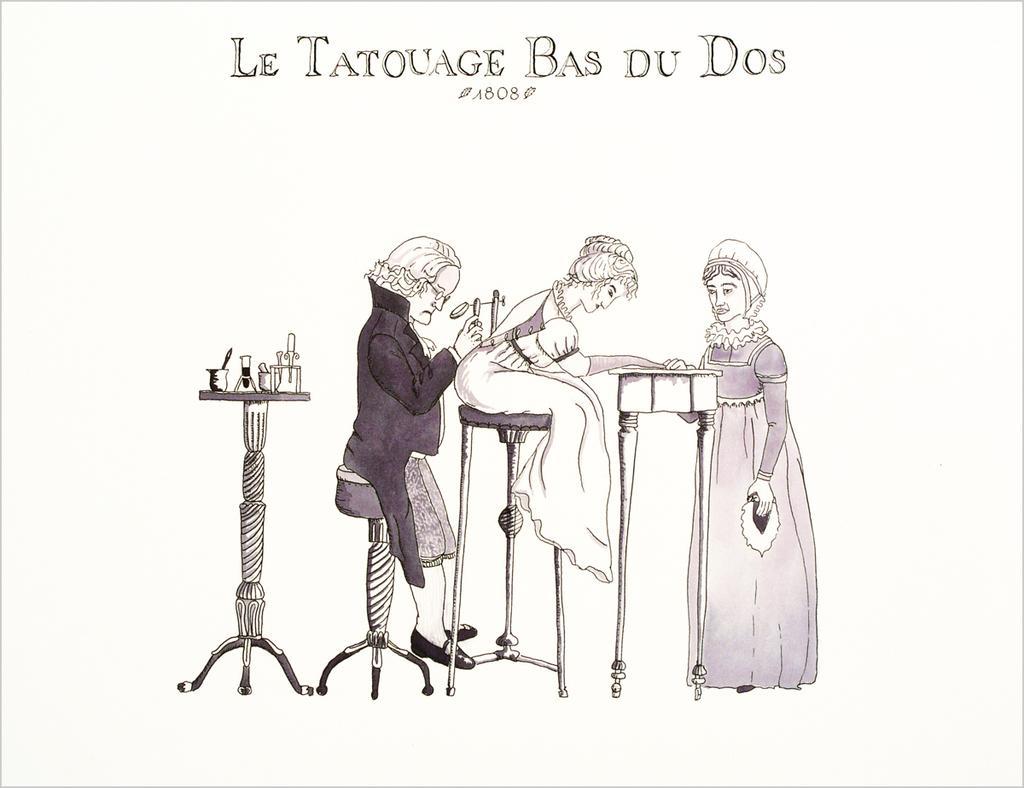Please provide a concise description of this image. This is an animated image, where there is a measuring jug and some objects on the table, two persons are sitting on the stools, a person standing near a table. 